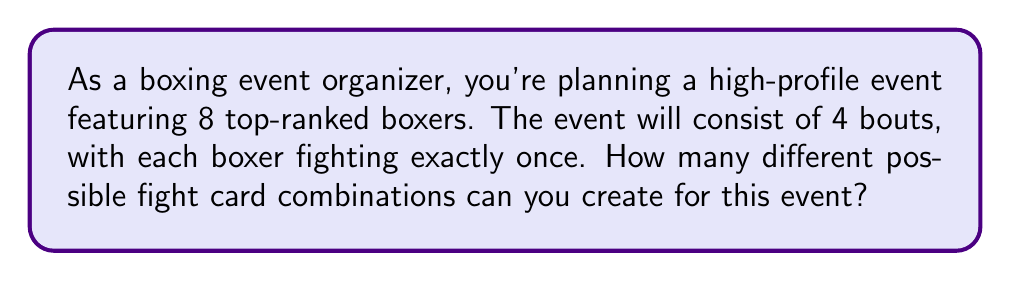Could you help me with this problem? Let's approach this step-by-step:

1) First, we need to understand that we're essentially pairing up the 8 boxers into 4 bouts.

2) For the first bout, we have $\binom{8}{2}$ ways to choose 2 boxers from 8. This can be calculated as:

   $$\binom{8}{2} = \frac{8!}{2!(8-2)!} = \frac{8 \cdot 7}{2 \cdot 1} = 28$$

3) After the first bout is set, we have 6 boxers left. For the second bout, we have $\binom{6}{2}$ ways to choose 2 boxers from 6:

   $$\binom{6}{2} = \frac{6!}{2!(6-2)!} = \frac{6 \cdot 5}{2 \cdot 1} = 15$$

4) For the third bout, we have 4 boxers left, giving us $\binom{4}{2}$ choices:

   $$\binom{4}{2} = \frac{4!}{2!(4-2)!} = \frac{4 \cdot 3}{2 \cdot 1} = 6$$

5) The last bout is determined by the remaining 2 boxers, so there's only 1 way to arrange this.

6) According to the multiplication principle, the total number of possible fight card combinations is the product of all these choices:

   $$28 \cdot 15 \cdot 6 \cdot 1 = 2,520$$

Therefore, there are 2,520 different possible fight card combinations for this event.
Answer: 2,520 possible fight card combinations 